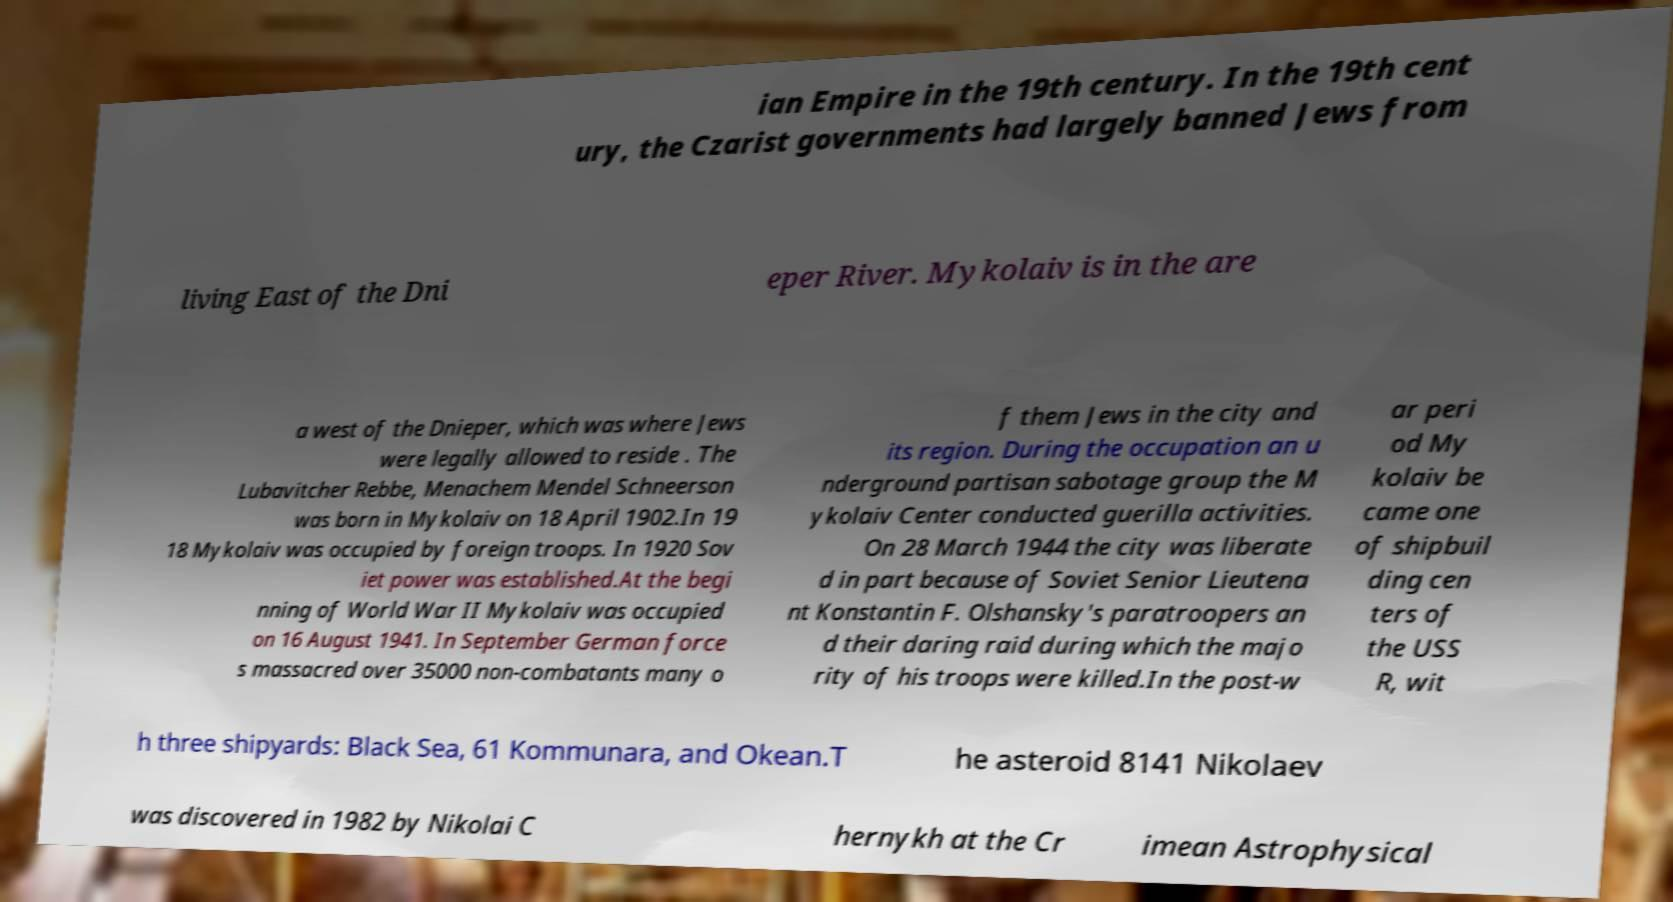Can you accurately transcribe the text from the provided image for me? ian Empire in the 19th century. In the 19th cent ury, the Czarist governments had largely banned Jews from living East of the Dni eper River. Mykolaiv is in the are a west of the Dnieper, which was where Jews were legally allowed to reside . The Lubavitcher Rebbe, Menachem Mendel Schneerson was born in Mykolaiv on 18 April 1902.In 19 18 Mykolaiv was occupied by foreign troops. In 1920 Sov iet power was established.At the begi nning of World War II Mykolaiv was occupied on 16 August 1941. In September German force s massacred over 35000 non-combatants many o f them Jews in the city and its region. During the occupation an u nderground partisan sabotage group the M ykolaiv Center conducted guerilla activities. On 28 March 1944 the city was liberate d in part because of Soviet Senior Lieutena nt Konstantin F. Olshansky's paratroopers an d their daring raid during which the majo rity of his troops were killed.In the post-w ar peri od My kolaiv be came one of shipbuil ding cen ters of the USS R, wit h three shipyards: Black Sea, 61 Kommunara, and Okean.T he asteroid 8141 Nikolaev was discovered in 1982 by Nikolai C hernykh at the Cr imean Astrophysical 